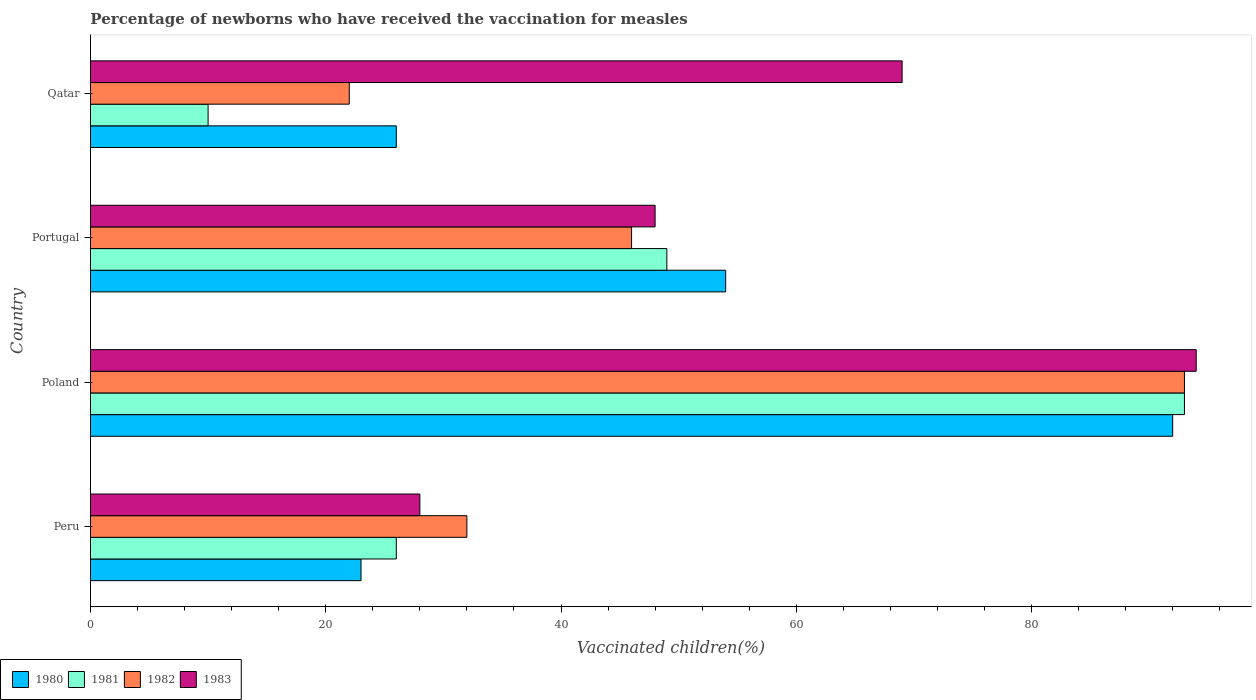How many different coloured bars are there?
Your answer should be compact. 4. Are the number of bars per tick equal to the number of legend labels?
Provide a short and direct response. Yes. Are the number of bars on each tick of the Y-axis equal?
Provide a succinct answer. Yes. How many bars are there on the 1st tick from the bottom?
Provide a succinct answer. 4. What is the label of the 2nd group of bars from the top?
Your answer should be very brief. Portugal. What is the percentage of vaccinated children in 1982 in Poland?
Provide a succinct answer. 93. Across all countries, what is the maximum percentage of vaccinated children in 1981?
Keep it short and to the point. 93. In which country was the percentage of vaccinated children in 1980 maximum?
Offer a terse response. Poland. In which country was the percentage of vaccinated children in 1981 minimum?
Make the answer very short. Qatar. What is the total percentage of vaccinated children in 1980 in the graph?
Your response must be concise. 195. What is the difference between the percentage of vaccinated children in 1981 in Peru and that in Qatar?
Your response must be concise. 16. What is the average percentage of vaccinated children in 1982 per country?
Provide a succinct answer. 48.25. What is the difference between the percentage of vaccinated children in 1980 and percentage of vaccinated children in 1983 in Qatar?
Your response must be concise. -43. What is the ratio of the percentage of vaccinated children in 1980 in Peru to that in Qatar?
Ensure brevity in your answer.  0.88. Is the percentage of vaccinated children in 1980 in Poland less than that in Qatar?
Offer a very short reply. No. What is the difference between the highest and the lowest percentage of vaccinated children in 1981?
Provide a succinct answer. 83. Is the sum of the percentage of vaccinated children in 1982 in Peru and Qatar greater than the maximum percentage of vaccinated children in 1980 across all countries?
Ensure brevity in your answer.  No. What does the 3rd bar from the bottom in Qatar represents?
Ensure brevity in your answer.  1982. Is it the case that in every country, the sum of the percentage of vaccinated children in 1982 and percentage of vaccinated children in 1980 is greater than the percentage of vaccinated children in 1981?
Keep it short and to the point. Yes. How many bars are there?
Your answer should be compact. 16. How many countries are there in the graph?
Offer a very short reply. 4. What is the difference between two consecutive major ticks on the X-axis?
Make the answer very short. 20. Are the values on the major ticks of X-axis written in scientific E-notation?
Provide a succinct answer. No. Does the graph contain grids?
Your answer should be compact. No. What is the title of the graph?
Your response must be concise. Percentage of newborns who have received the vaccination for measles. Does "2015" appear as one of the legend labels in the graph?
Your answer should be very brief. No. What is the label or title of the X-axis?
Make the answer very short. Vaccinated children(%). What is the Vaccinated children(%) in 1980 in Peru?
Make the answer very short. 23. What is the Vaccinated children(%) in 1981 in Peru?
Offer a very short reply. 26. What is the Vaccinated children(%) in 1982 in Peru?
Provide a succinct answer. 32. What is the Vaccinated children(%) of 1983 in Peru?
Ensure brevity in your answer.  28. What is the Vaccinated children(%) of 1980 in Poland?
Provide a succinct answer. 92. What is the Vaccinated children(%) in 1981 in Poland?
Offer a very short reply. 93. What is the Vaccinated children(%) in 1982 in Poland?
Offer a terse response. 93. What is the Vaccinated children(%) in 1983 in Poland?
Provide a succinct answer. 94. What is the Vaccinated children(%) in 1980 in Qatar?
Provide a succinct answer. 26. Across all countries, what is the maximum Vaccinated children(%) of 1980?
Offer a terse response. 92. Across all countries, what is the maximum Vaccinated children(%) of 1981?
Ensure brevity in your answer.  93. Across all countries, what is the maximum Vaccinated children(%) of 1982?
Your answer should be compact. 93. Across all countries, what is the maximum Vaccinated children(%) in 1983?
Provide a short and direct response. 94. Across all countries, what is the minimum Vaccinated children(%) of 1980?
Your answer should be very brief. 23. Across all countries, what is the minimum Vaccinated children(%) of 1982?
Make the answer very short. 22. Across all countries, what is the minimum Vaccinated children(%) in 1983?
Provide a succinct answer. 28. What is the total Vaccinated children(%) of 1980 in the graph?
Provide a short and direct response. 195. What is the total Vaccinated children(%) of 1981 in the graph?
Your answer should be very brief. 178. What is the total Vaccinated children(%) in 1982 in the graph?
Provide a short and direct response. 193. What is the total Vaccinated children(%) in 1983 in the graph?
Give a very brief answer. 239. What is the difference between the Vaccinated children(%) of 1980 in Peru and that in Poland?
Provide a short and direct response. -69. What is the difference between the Vaccinated children(%) in 1981 in Peru and that in Poland?
Provide a succinct answer. -67. What is the difference between the Vaccinated children(%) in 1982 in Peru and that in Poland?
Offer a terse response. -61. What is the difference between the Vaccinated children(%) of 1983 in Peru and that in Poland?
Offer a very short reply. -66. What is the difference between the Vaccinated children(%) in 1980 in Peru and that in Portugal?
Your answer should be very brief. -31. What is the difference between the Vaccinated children(%) in 1981 in Peru and that in Portugal?
Your answer should be compact. -23. What is the difference between the Vaccinated children(%) in 1981 in Peru and that in Qatar?
Offer a terse response. 16. What is the difference between the Vaccinated children(%) in 1983 in Peru and that in Qatar?
Offer a terse response. -41. What is the difference between the Vaccinated children(%) of 1981 in Poland and that in Portugal?
Provide a succinct answer. 44. What is the difference between the Vaccinated children(%) in 1983 in Poland and that in Portugal?
Give a very brief answer. 46. What is the difference between the Vaccinated children(%) in 1980 in Poland and that in Qatar?
Offer a very short reply. 66. What is the difference between the Vaccinated children(%) of 1981 in Poland and that in Qatar?
Provide a short and direct response. 83. What is the difference between the Vaccinated children(%) in 1981 in Portugal and that in Qatar?
Ensure brevity in your answer.  39. What is the difference between the Vaccinated children(%) in 1983 in Portugal and that in Qatar?
Provide a succinct answer. -21. What is the difference between the Vaccinated children(%) in 1980 in Peru and the Vaccinated children(%) in 1981 in Poland?
Offer a very short reply. -70. What is the difference between the Vaccinated children(%) of 1980 in Peru and the Vaccinated children(%) of 1982 in Poland?
Provide a short and direct response. -70. What is the difference between the Vaccinated children(%) in 1980 in Peru and the Vaccinated children(%) in 1983 in Poland?
Offer a terse response. -71. What is the difference between the Vaccinated children(%) of 1981 in Peru and the Vaccinated children(%) of 1982 in Poland?
Offer a very short reply. -67. What is the difference between the Vaccinated children(%) of 1981 in Peru and the Vaccinated children(%) of 1983 in Poland?
Give a very brief answer. -68. What is the difference between the Vaccinated children(%) of 1982 in Peru and the Vaccinated children(%) of 1983 in Poland?
Ensure brevity in your answer.  -62. What is the difference between the Vaccinated children(%) in 1980 in Peru and the Vaccinated children(%) in 1981 in Portugal?
Make the answer very short. -26. What is the difference between the Vaccinated children(%) in 1980 in Peru and the Vaccinated children(%) in 1982 in Portugal?
Your answer should be very brief. -23. What is the difference between the Vaccinated children(%) in 1981 in Peru and the Vaccinated children(%) in 1982 in Portugal?
Provide a short and direct response. -20. What is the difference between the Vaccinated children(%) of 1981 in Peru and the Vaccinated children(%) of 1983 in Portugal?
Your response must be concise. -22. What is the difference between the Vaccinated children(%) of 1982 in Peru and the Vaccinated children(%) of 1983 in Portugal?
Keep it short and to the point. -16. What is the difference between the Vaccinated children(%) of 1980 in Peru and the Vaccinated children(%) of 1982 in Qatar?
Your answer should be very brief. 1. What is the difference between the Vaccinated children(%) in 1980 in Peru and the Vaccinated children(%) in 1983 in Qatar?
Offer a very short reply. -46. What is the difference between the Vaccinated children(%) in 1981 in Peru and the Vaccinated children(%) in 1983 in Qatar?
Provide a short and direct response. -43. What is the difference between the Vaccinated children(%) in 1982 in Peru and the Vaccinated children(%) in 1983 in Qatar?
Make the answer very short. -37. What is the difference between the Vaccinated children(%) of 1980 in Poland and the Vaccinated children(%) of 1982 in Portugal?
Keep it short and to the point. 46. What is the difference between the Vaccinated children(%) in 1981 in Poland and the Vaccinated children(%) in 1982 in Portugal?
Keep it short and to the point. 47. What is the difference between the Vaccinated children(%) of 1981 in Poland and the Vaccinated children(%) of 1983 in Portugal?
Your response must be concise. 45. What is the difference between the Vaccinated children(%) of 1980 in Poland and the Vaccinated children(%) of 1981 in Qatar?
Provide a succinct answer. 82. What is the difference between the Vaccinated children(%) in 1980 in Poland and the Vaccinated children(%) in 1982 in Qatar?
Ensure brevity in your answer.  70. What is the difference between the Vaccinated children(%) in 1982 in Poland and the Vaccinated children(%) in 1983 in Qatar?
Offer a terse response. 24. What is the average Vaccinated children(%) in 1980 per country?
Give a very brief answer. 48.75. What is the average Vaccinated children(%) in 1981 per country?
Ensure brevity in your answer.  44.5. What is the average Vaccinated children(%) in 1982 per country?
Your answer should be compact. 48.25. What is the average Vaccinated children(%) in 1983 per country?
Keep it short and to the point. 59.75. What is the difference between the Vaccinated children(%) in 1981 and Vaccinated children(%) in 1982 in Peru?
Your response must be concise. -6. What is the difference between the Vaccinated children(%) of 1982 and Vaccinated children(%) of 1983 in Peru?
Keep it short and to the point. 4. What is the difference between the Vaccinated children(%) of 1980 and Vaccinated children(%) of 1981 in Poland?
Provide a short and direct response. -1. What is the difference between the Vaccinated children(%) in 1980 and Vaccinated children(%) in 1981 in Portugal?
Offer a terse response. 5. What is the difference between the Vaccinated children(%) of 1980 and Vaccinated children(%) of 1982 in Portugal?
Your response must be concise. 8. What is the difference between the Vaccinated children(%) in 1980 and Vaccinated children(%) in 1983 in Portugal?
Give a very brief answer. 6. What is the difference between the Vaccinated children(%) in 1981 and Vaccinated children(%) in 1983 in Portugal?
Your answer should be very brief. 1. What is the difference between the Vaccinated children(%) in 1982 and Vaccinated children(%) in 1983 in Portugal?
Ensure brevity in your answer.  -2. What is the difference between the Vaccinated children(%) in 1980 and Vaccinated children(%) in 1982 in Qatar?
Your answer should be very brief. 4. What is the difference between the Vaccinated children(%) in 1980 and Vaccinated children(%) in 1983 in Qatar?
Offer a very short reply. -43. What is the difference between the Vaccinated children(%) of 1981 and Vaccinated children(%) of 1982 in Qatar?
Make the answer very short. -12. What is the difference between the Vaccinated children(%) in 1981 and Vaccinated children(%) in 1983 in Qatar?
Give a very brief answer. -59. What is the difference between the Vaccinated children(%) in 1982 and Vaccinated children(%) in 1983 in Qatar?
Your answer should be compact. -47. What is the ratio of the Vaccinated children(%) in 1981 in Peru to that in Poland?
Give a very brief answer. 0.28. What is the ratio of the Vaccinated children(%) of 1982 in Peru to that in Poland?
Give a very brief answer. 0.34. What is the ratio of the Vaccinated children(%) in 1983 in Peru to that in Poland?
Ensure brevity in your answer.  0.3. What is the ratio of the Vaccinated children(%) in 1980 in Peru to that in Portugal?
Your answer should be compact. 0.43. What is the ratio of the Vaccinated children(%) of 1981 in Peru to that in Portugal?
Your answer should be compact. 0.53. What is the ratio of the Vaccinated children(%) of 1982 in Peru to that in Portugal?
Make the answer very short. 0.7. What is the ratio of the Vaccinated children(%) in 1983 in Peru to that in Portugal?
Provide a succinct answer. 0.58. What is the ratio of the Vaccinated children(%) of 1980 in Peru to that in Qatar?
Your answer should be compact. 0.88. What is the ratio of the Vaccinated children(%) of 1982 in Peru to that in Qatar?
Make the answer very short. 1.45. What is the ratio of the Vaccinated children(%) of 1983 in Peru to that in Qatar?
Your response must be concise. 0.41. What is the ratio of the Vaccinated children(%) of 1980 in Poland to that in Portugal?
Keep it short and to the point. 1.7. What is the ratio of the Vaccinated children(%) in 1981 in Poland to that in Portugal?
Offer a very short reply. 1.9. What is the ratio of the Vaccinated children(%) in 1982 in Poland to that in Portugal?
Give a very brief answer. 2.02. What is the ratio of the Vaccinated children(%) of 1983 in Poland to that in Portugal?
Your answer should be compact. 1.96. What is the ratio of the Vaccinated children(%) of 1980 in Poland to that in Qatar?
Make the answer very short. 3.54. What is the ratio of the Vaccinated children(%) of 1982 in Poland to that in Qatar?
Ensure brevity in your answer.  4.23. What is the ratio of the Vaccinated children(%) in 1983 in Poland to that in Qatar?
Offer a terse response. 1.36. What is the ratio of the Vaccinated children(%) of 1980 in Portugal to that in Qatar?
Offer a very short reply. 2.08. What is the ratio of the Vaccinated children(%) of 1982 in Portugal to that in Qatar?
Your response must be concise. 2.09. What is the ratio of the Vaccinated children(%) of 1983 in Portugal to that in Qatar?
Your answer should be very brief. 0.7. What is the difference between the highest and the second highest Vaccinated children(%) in 1983?
Your answer should be compact. 25. What is the difference between the highest and the lowest Vaccinated children(%) of 1980?
Make the answer very short. 69. 